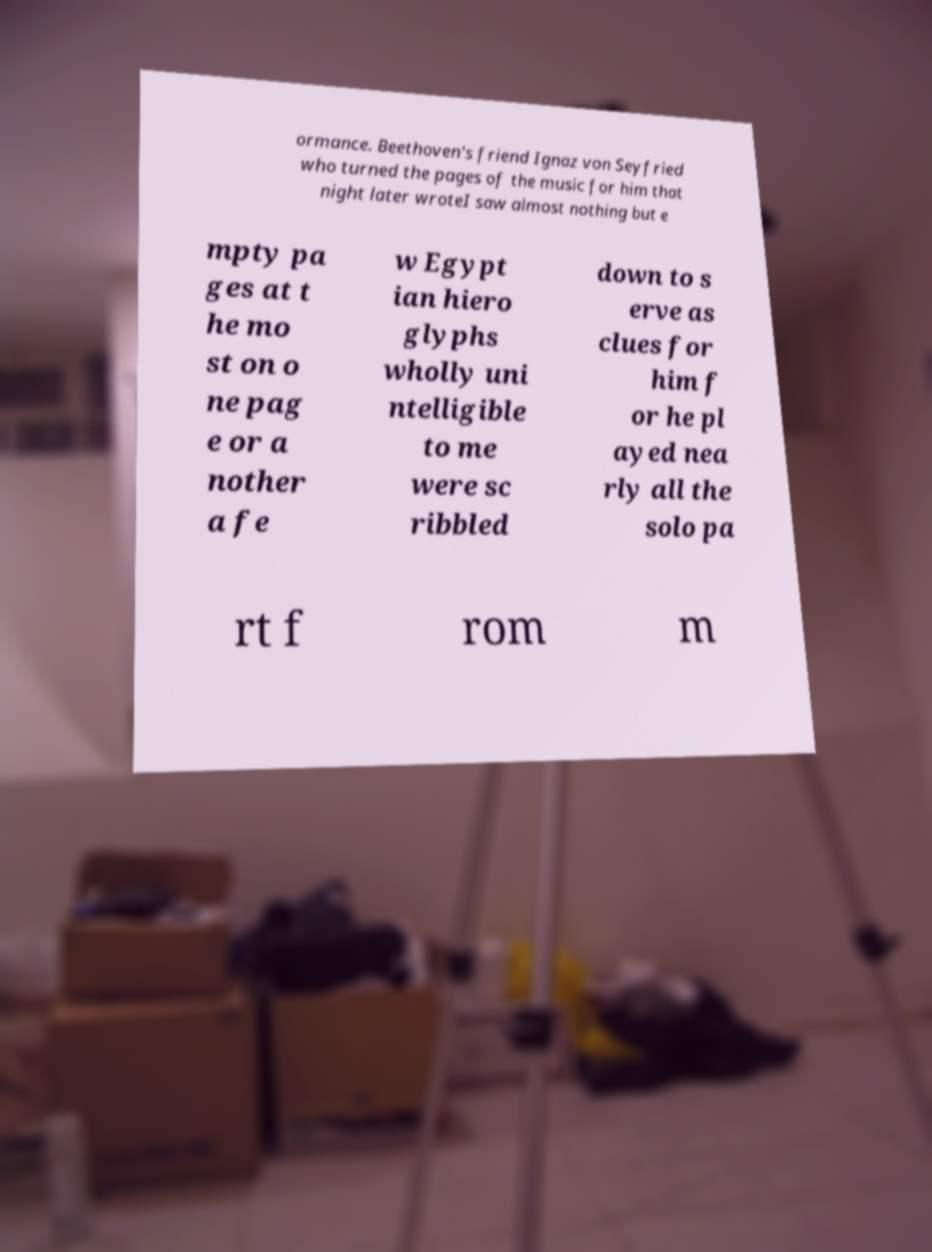For documentation purposes, I need the text within this image transcribed. Could you provide that? ormance. Beethoven's friend Ignaz von Seyfried who turned the pages of the music for him that night later wroteI saw almost nothing but e mpty pa ges at t he mo st on o ne pag e or a nother a fe w Egypt ian hiero glyphs wholly uni ntelligible to me were sc ribbled down to s erve as clues for him f or he pl ayed nea rly all the solo pa rt f rom m 